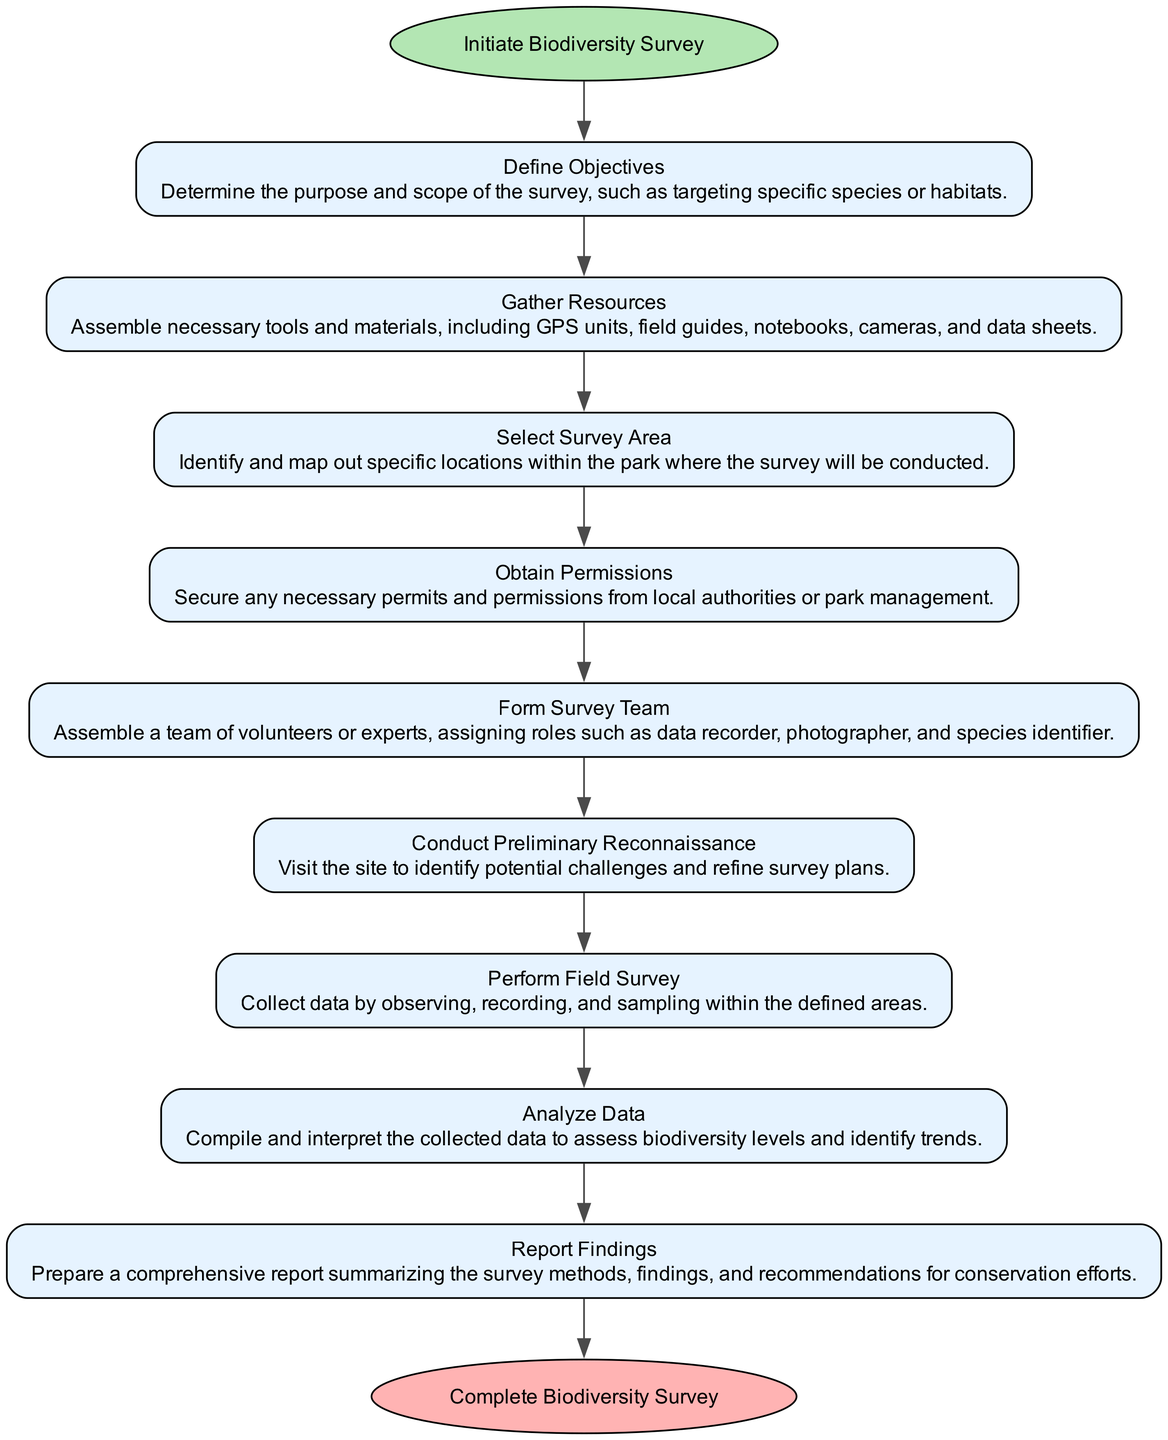What is the first step in the biodiversity survey? The first step is represented by the starting node labeled "Initiate Biodiversity Survey." This indicates the beginning of the process.
Answer: Initiate Biodiversity Survey How many total steps are there in the flow chart? By counting the nodes representing the steps in the chart, we see there are 9 process steps plus the start and end nodes, totaling 11 nodes. However, the steps to conduct the survey are 9.
Answer: 9 What is the last step of the biodiversity survey? The last node leading from the final step in the flow chart is labeled "Complete Biodiversity Survey," indicating the conclusion of the process.
Answer: Complete Biodiversity Survey What must be assembled before conducting the survey? According to the flow chart, the step titled "Gather Resources" specifies that necessary tools and materials must be assembled prior to the survey.
Answer: Tools and materials Which step comes immediately after obtaining permissions? The flow chart shows that "Form Survey Team" is the step that follows directly after "Obtain Permissions," creating a sequence in the survey process.
Answer: Form Survey Team In the survey process, what comes after defining objectives? The flow chart details that after defining the objectives, the next step is to "Gather Resources," which indicates the order of actions taken in the survey process.
Answer: Gather Resources What is the main goal of the step labeled "Analyze Data"? The label "Analyze Data" indicates that the goal of this step is to compile and interpret collected data to assess biodiversity levels, highlighting the importance of this stage in understanding survey results.
Answer: Assess biodiversity levels What role is specifically mentioned in forming the survey team? The step "Form Survey Team" specifies roles such as "data recorder," indicating a particular function among the assigned team members.
Answer: Data recorder What does the preliminary reconnaissance help to identify? The step labeled "Conduct Preliminary Reconnaissance" focuses on identifying potential challenges on site, which aids in refining the survey plans for better execution.
Answer: Potential challenges 